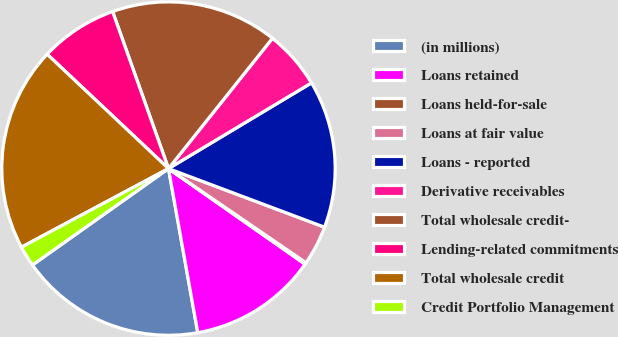Convert chart to OTSL. <chart><loc_0><loc_0><loc_500><loc_500><pie_chart><fcel>(in millions)<fcel>Loans retained<fcel>Loans held-for-sale<fcel>Loans at fair value<fcel>Loans - reported<fcel>Derivative receivables<fcel>Total wholesale credit-<fcel>Lending-related commitments<fcel>Total wholesale credit<fcel>Credit Portfolio Management<nl><fcel>18.0%<fcel>12.47%<fcel>0.16%<fcel>3.84%<fcel>14.31%<fcel>5.69%<fcel>16.16%<fcel>7.53%<fcel>19.84%<fcel>2.0%<nl></chart> 